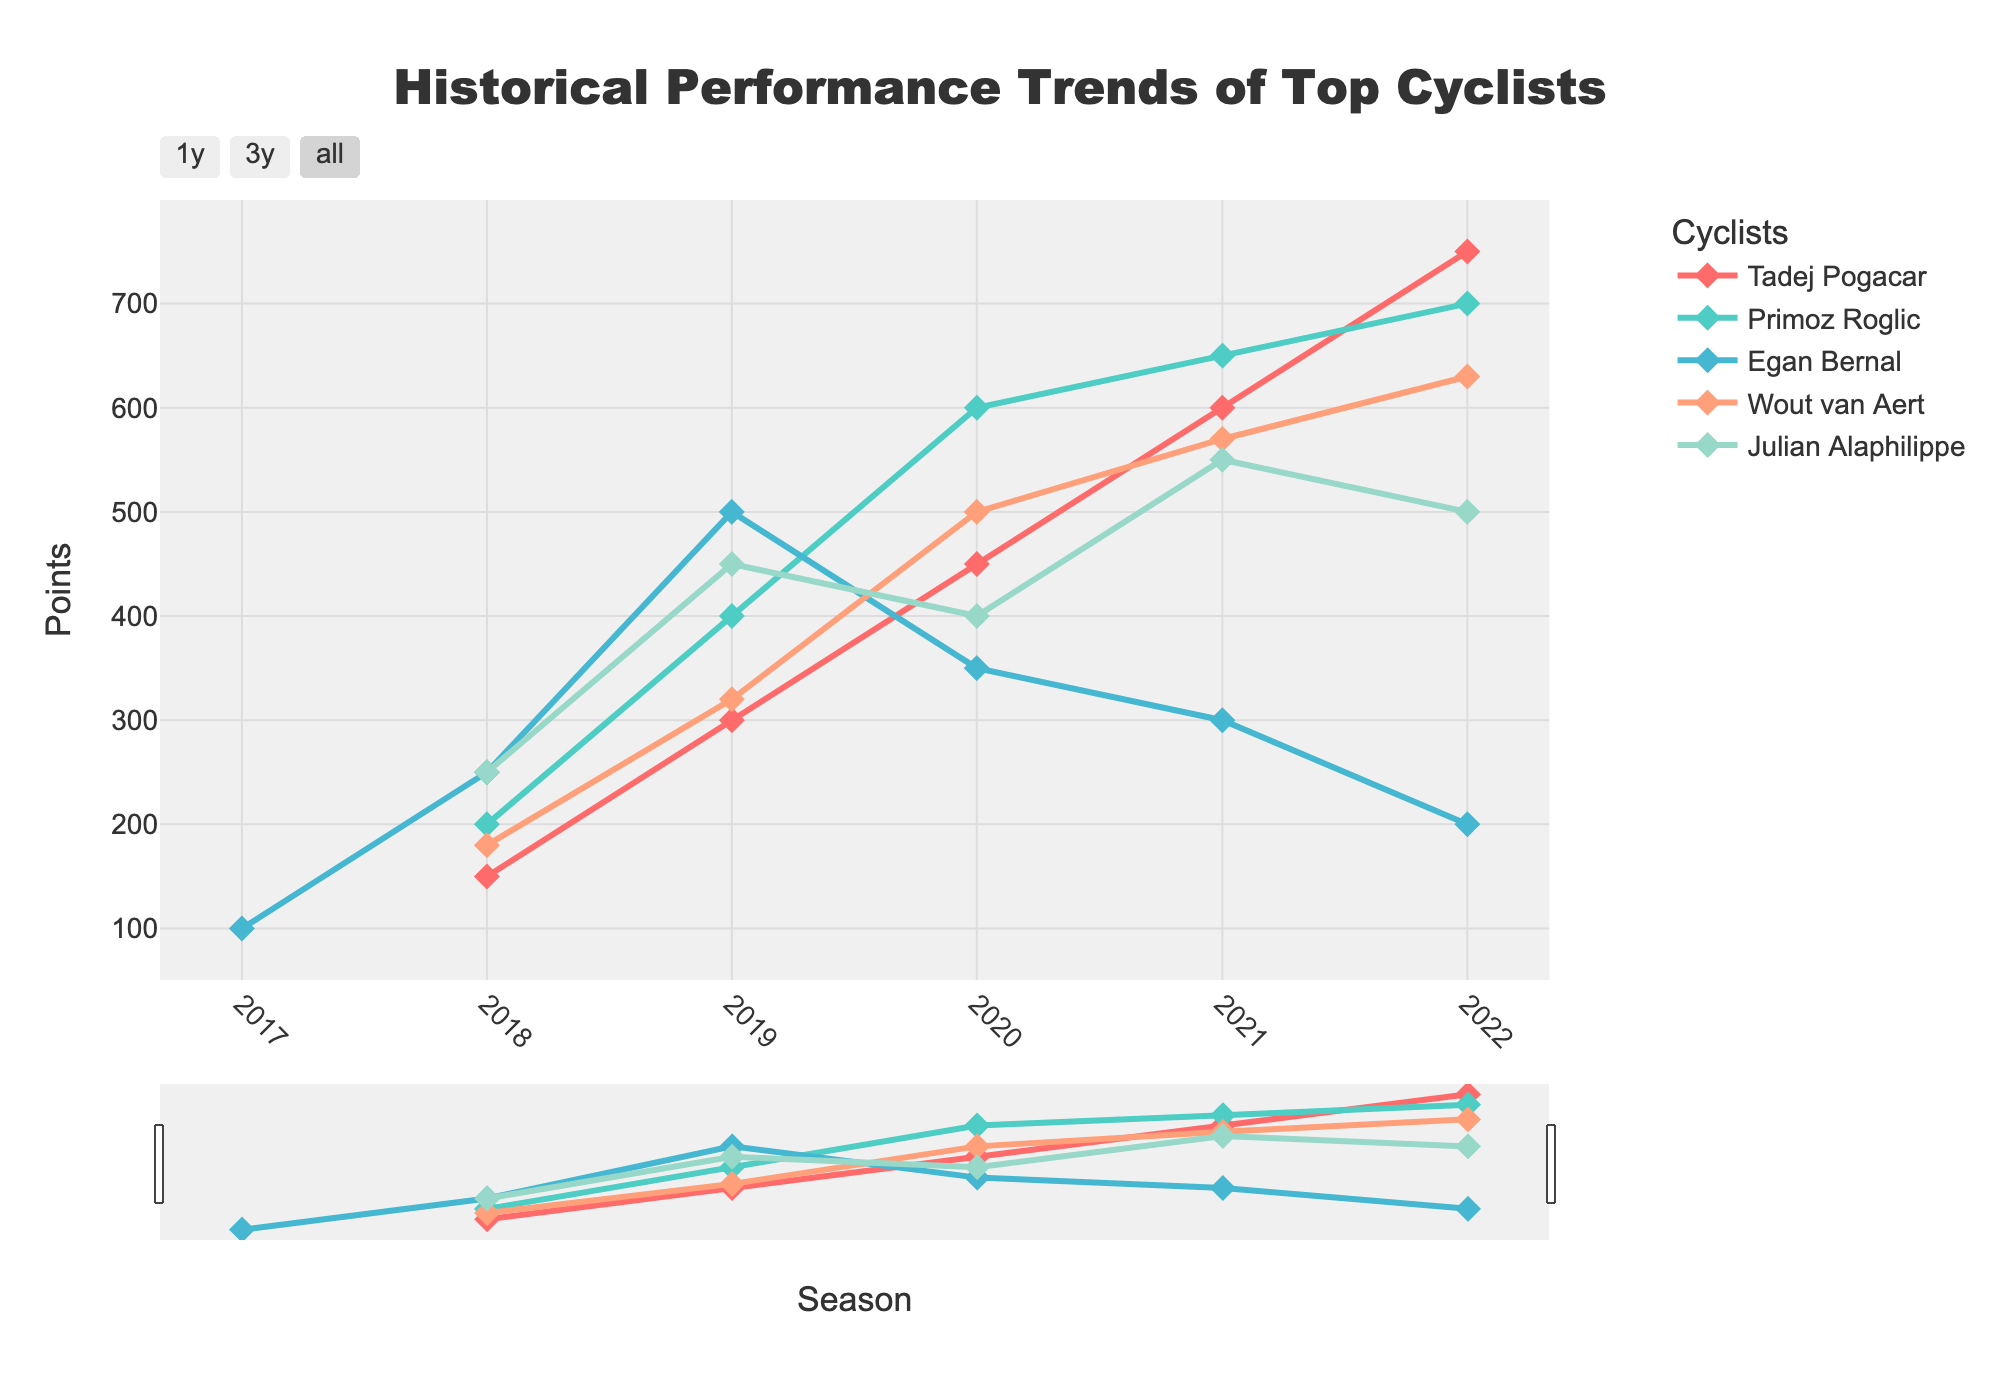what is the title of the figure? The title is displayed at the top center of the figure. It reads "Historical Performance Trends of Top Cyclists", indicating the topic of the plot.
Answer: Historical Performance Trends of Top Cyclists What cyclist had the highest points in 2022? In the 2022 season, Tadej Pogacar is the cyclist with the highest number of points. This is seen at the end of Tadej Pogacar's time series line, which reaches the highest point among all cyclists.
Answer: Tadej Pogacar How many cyclists are represented in this figure? The legend on the right side of the figure lists the names of all cyclists included. There are five names: Tadej Pogacar, Primoz Roglic, Egan Bernal, Wout van Aert, and Julian Alaphilippe.
Answer: 5 Which cyclist showed a decline in points after reaching their peak? Egan Bernal had a peak in points in 2019 and then showed a decline in subsequent years (2020, 2021, and 2022). This trend can be seen by observing the downward trajectory in Egan Bernal's time series line after 2019.
Answer: Egan Bernal Which two cyclists had the closest points in the 2022 season? Tadej Pogacar and Primoz Roglic had the closest points in 2022. By comparing the endpoint of their respective lines in 2022, we see that their points are very close, with Tadej Pogacar having a slight edge.
Answer: Tadej Pogacar and Primoz Roglic What is the average number of points for Wout van Aert over all seasons? Wout van Aert's points over the seasons are 180, 320, 500, 570, and 630. Adding these values gives 2200. Dividing this sum by the number of seasons (5) gives the average.
Answer: 440 Between Primoz Roglic and Julian Alaphilippe, who had better performance improvement between 2018 and 2019? Primoz Roglic improved from 200 points in 2018 to 400 points in 2019, a difference of 200 points. Julian Alaphilippe improved from 250 points in 2018 to 450 points in 2019, a difference of 200 points. Since both differences are equal, both had the same performance improvement.
Answer: Both Which cyclist had the steepest increase in points from one season to the next? Tadej Pogacar had the steepest increase between 2019 and 2020, where his points went from 300 to 450, an increase of 150 points in a single season. No other cyclist had a greater increase of points in one season.
Answer: Tadej Pogacar What is the trend in points for Julian Alaphilippe from 2020 to 2022? Julian Alaphilippe's points showed a slight increase from 2020 to 2021 (400 to 550) but then decreased from 2021 to 2022 (550 to 500), showing an overall fluctuating trend.
Answer: Fluctuating Which cyclist has consistently increased their points each season? Tadej Pogacar is the only cyclist whose points have consistently increased each season from 2018 to 2022. This is visible through the consistently upward trajectory of his time series line.
Answer: Tadej Pogacar 